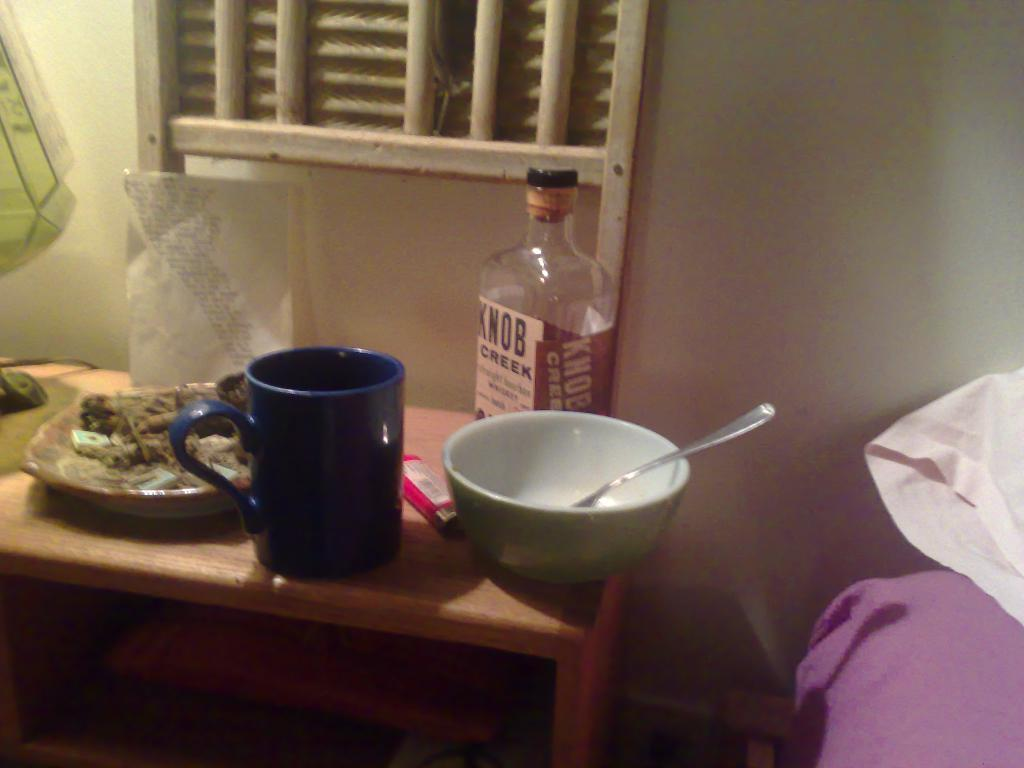Provide a one-sentence caption for the provided image. A bottle of Knob Creek Bourbon sitting on a table with other stuff. 